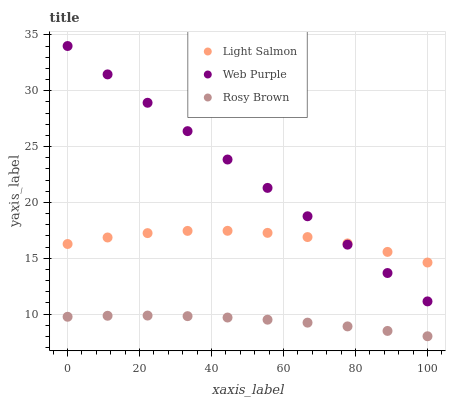Does Rosy Brown have the minimum area under the curve?
Answer yes or no. Yes. Does Web Purple have the maximum area under the curve?
Answer yes or no. Yes. Does Web Purple have the minimum area under the curve?
Answer yes or no. No. Does Rosy Brown have the maximum area under the curve?
Answer yes or no. No. Is Web Purple the smoothest?
Answer yes or no. Yes. Is Light Salmon the roughest?
Answer yes or no. Yes. Is Rosy Brown the smoothest?
Answer yes or no. No. Is Rosy Brown the roughest?
Answer yes or no. No. Does Rosy Brown have the lowest value?
Answer yes or no. Yes. Does Web Purple have the lowest value?
Answer yes or no. No. Does Web Purple have the highest value?
Answer yes or no. Yes. Does Rosy Brown have the highest value?
Answer yes or no. No. Is Rosy Brown less than Light Salmon?
Answer yes or no. Yes. Is Light Salmon greater than Rosy Brown?
Answer yes or no. Yes. Does Web Purple intersect Light Salmon?
Answer yes or no. Yes. Is Web Purple less than Light Salmon?
Answer yes or no. No. Is Web Purple greater than Light Salmon?
Answer yes or no. No. Does Rosy Brown intersect Light Salmon?
Answer yes or no. No. 